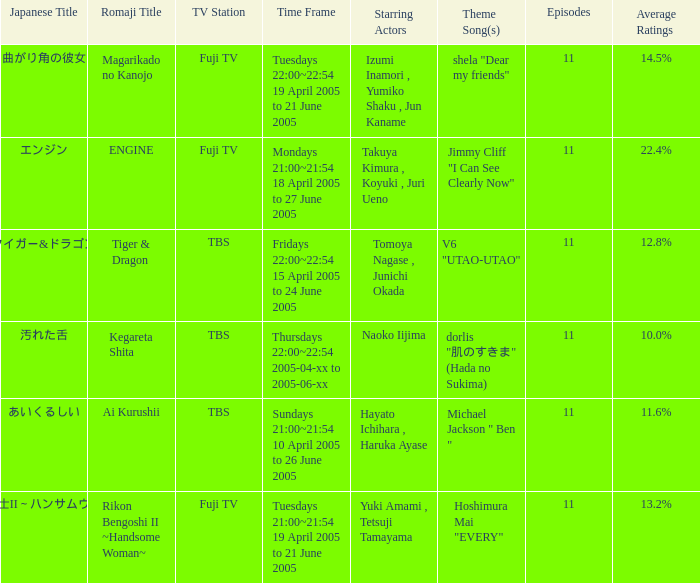What is the Japanese title with an average rating of 11.6%? あいくるしい. Write the full table. {'header': ['Japanese Title', 'Romaji Title', 'TV Station', 'Time Frame', 'Starring Actors', 'Theme Song(s)', 'Episodes', 'Average Ratings'], 'rows': [['曲がり角の彼女', 'Magarikado no Kanojo', 'Fuji TV', 'Tuesdays 22:00~22:54 19 April 2005 to 21 June 2005', 'Izumi Inamori , Yumiko Shaku , Jun Kaname', 'shela "Dear my friends"', '11', '14.5%'], ['エンジン', 'ENGINE', 'Fuji TV', 'Mondays 21:00~21:54 18 April 2005 to 27 June 2005', 'Takuya Kimura , Koyuki , Juri Ueno', 'Jimmy Cliff "I Can See Clearly Now"', '11', '22.4%'], ['タイガー&ドラゴン', 'Tiger & Dragon', 'TBS', 'Fridays 22:00~22:54 15 April 2005 to 24 June 2005', 'Tomoya Nagase , Junichi Okada', 'V6 "UTAO-UTAO"', '11', '12.8%'], ['汚れた舌', 'Kegareta Shita', 'TBS', 'Thursdays 22:00~22:54 2005-04-xx to 2005-06-xx', 'Naoko Iijima', 'dorlis "肌のすきま" (Hada no Sukima)', '11', '10.0%'], ['あいくるしい', 'Ai Kurushii', 'TBS', 'Sundays 21:00~21:54 10 April 2005 to 26 June 2005', 'Hayato Ichihara , Haruka Ayase', 'Michael Jackson " Ben "', '11', '11.6%'], ['離婚弁護士II～ハンサムウーマン～', 'Rikon Bengoshi II ~Handsome Woman~', 'Fuji TV', 'Tuesdays 21:00~21:54 19 April 2005 to 21 June 2005', 'Yuki Amami , Tetsuji Tamayama', 'Hoshimura Mai "EVERY"', '11', '13.2%']]} 